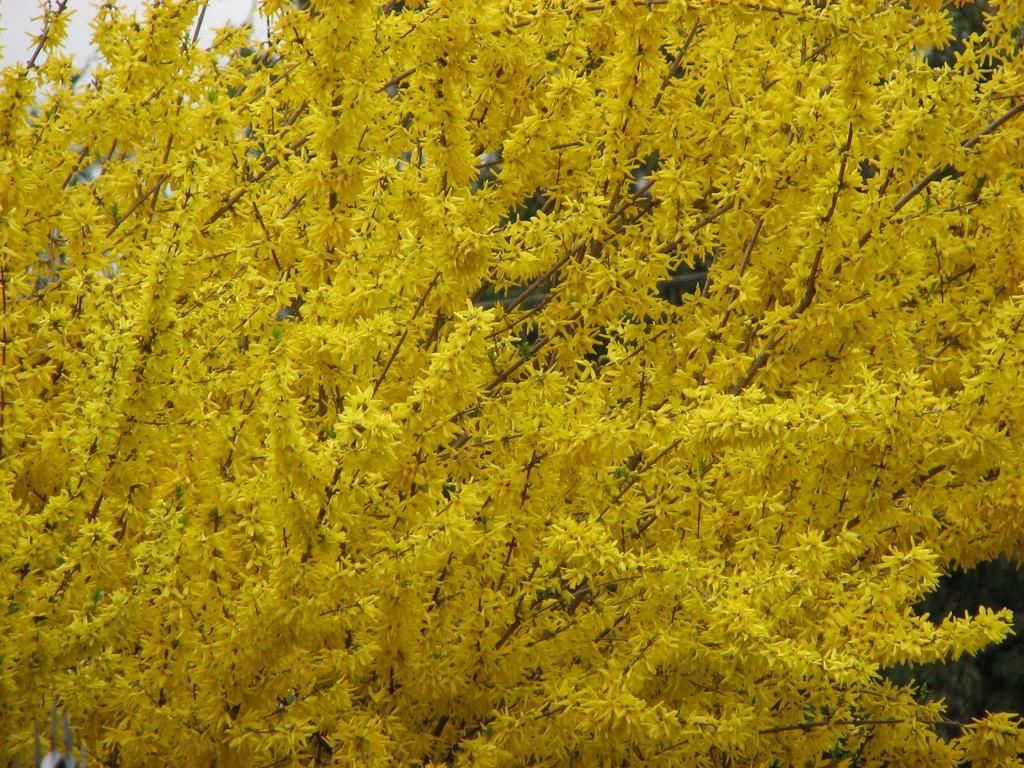How would you summarize this image in a sentence or two? In this picture we can see trees. In the background we can see sky. 